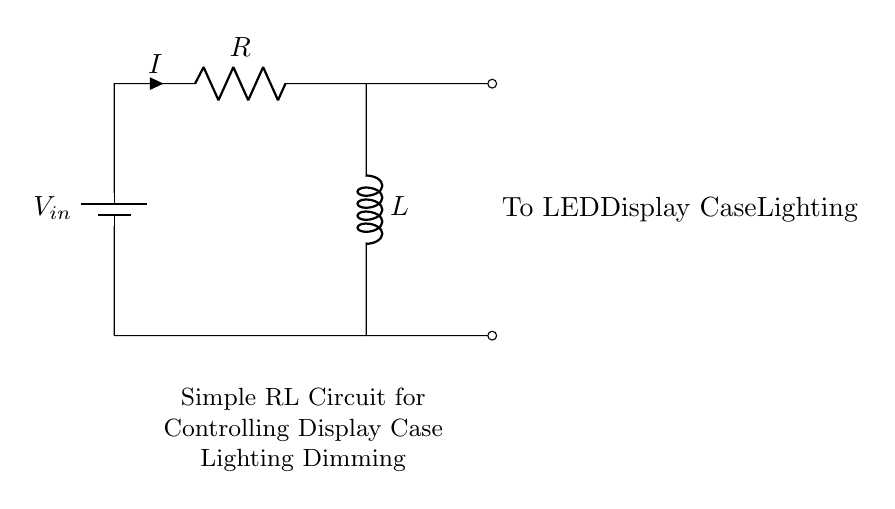What is the type of this circuit? The circuit is an RL circuit, which consists of a resistor and an inductor. This is indicated by the components labeled R and L in the diagram.
Answer: RL circuit What does the 'V in' label represent? The 'V in' label indicates the input voltage source for the circuit. It is connected at the top of the circuit and provides the power needed to drive the current through the components.
Answer: Input voltage What is the purpose of the resistor in this circuit? The resistor (labeled R) controls the current flow, dissipates power as heat, and works with the inductor to affect the dimming of the display case lighting based on the voltage across it.
Answer: Current control How does the inductor affect the circuit's response? The inductor (labeled L) stores energy in a magnetic field when current passes through it. This characteristic slows down the rate of change of current, creating a delay in the circuit's response which can affect how quickly the lighting dims or brightens.
Answer: Slows current change What happens when the input voltage increases? When the input voltage increases, the current through the resistor increases according to Ohm's Law. This leads to a greater energy being stored in the inductor, causing the LED lighting to become brighter. The circuit responds dynamically to changes in voltage.
Answer: LED brightness increases What is the effect of increasing the resistor value on the LED? Increasing the resistor value decreases the current flowing through the circuit. A lower current results in reduced power to the LED, making the display lighting dimmer. This can be useful for controlling brightness levels.
Answer: LED dims How do the connections impact the lighting functionality? The connections in the circuit create a closed loop between the battery, resistor, and inductor. This allows current to flow continuously to the LED display case lighting, enabling proper operation. If any connection is broken, the LED will not light up.
Answer: Ensures continuous current flow 